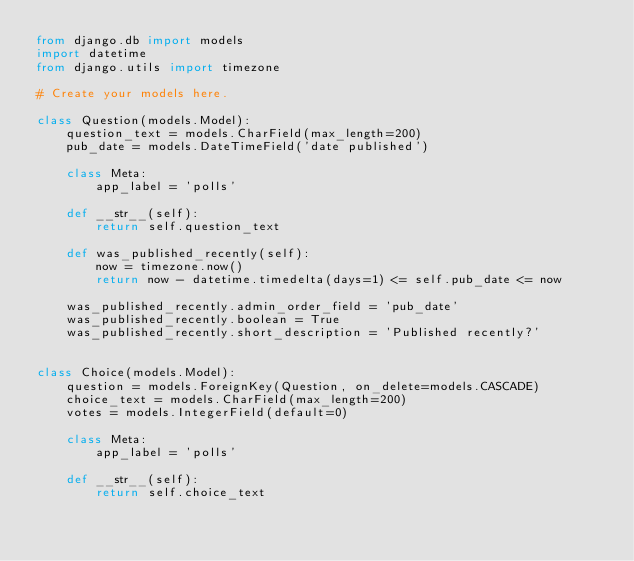<code> <loc_0><loc_0><loc_500><loc_500><_Python_>from django.db import models
import datetime
from django.utils import timezone

# Create your models here.

class Question(models.Model):
    question_text = models.CharField(max_length=200)
    pub_date = models.DateTimeField('date published')

    class Meta:
        app_label = 'polls'

    def __str__(self):
        return self.question_text

    def was_published_recently(self):
        now = timezone.now()
        return now - datetime.timedelta(days=1) <= self.pub_date <= now

    was_published_recently.admin_order_field = 'pub_date'
    was_published_recently.boolean = True
    was_published_recently.short_description = 'Published recently?'


class Choice(models.Model):
    question = models.ForeignKey(Question, on_delete=models.CASCADE)
    choice_text = models.CharField(max_length=200)
    votes = models.IntegerField(default=0)

    class Meta:
        app_label = 'polls'

    def __str__(self):
        return self.choice_text</code> 